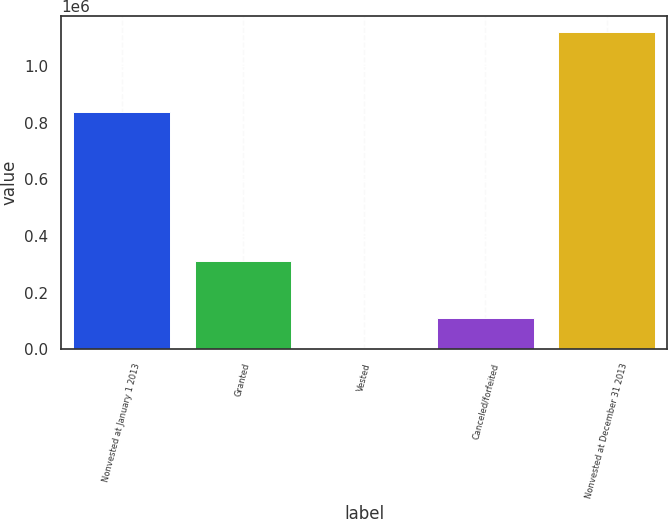<chart> <loc_0><loc_0><loc_500><loc_500><bar_chart><fcel>Nonvested at January 1 2013<fcel>Granted<fcel>Vested<fcel>Canceled/forfeited<fcel>Nonvested at December 31 2013<nl><fcel>836366<fcel>310610<fcel>2.67<fcel>112022<fcel>1.1202e+06<nl></chart> 